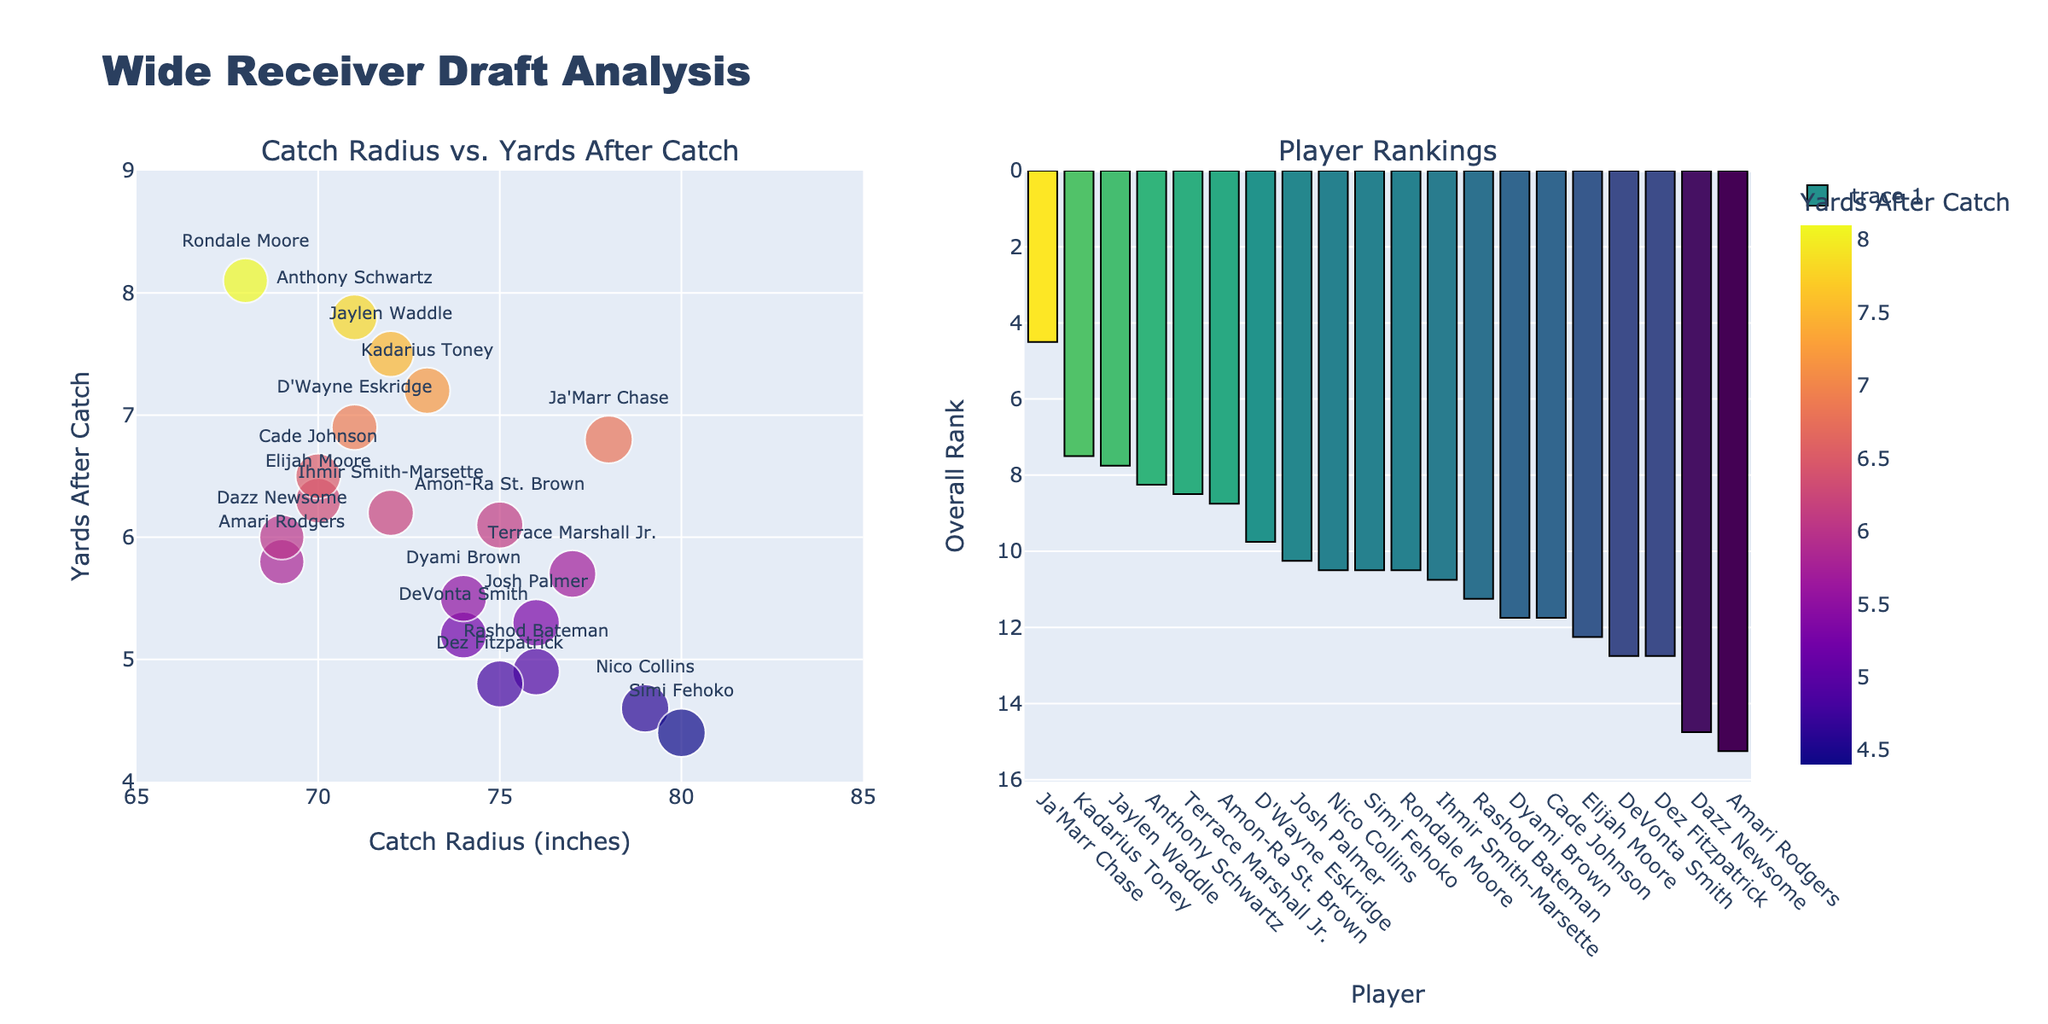What is the genre with the highest average word count? From the "Average Word Count" subplot, the highest bar belongs to the Fantasy genre.
Answer: Fantasy Which genre has the shortest chapter overall? Referring to the "Shortest Chapter" subplot, the shortest bar is for the Young Adult genre.
Answer: Young Adult Compare the standard deviations of Science Fiction and Horror; which is larger? In the "Standard Deviation" subplot, Science Fiction has a standard deviation of 2200 while Horror has 1500. Therefore, Science Fiction's standard deviation is larger.
Answer: Science Fiction What is the difference in the longest chapter length between Fantasy and Romance? In the "Longest Chapter" subplot, the longest chapter for Fantasy is 9500, and for Romance, it is 7500. The difference is 9500 - 7500.
Answer: 2000 Which two genres have the most similar average word count? From the "Average Word Count" subplot, Mystery (4500) and Literary Fiction (4200) have the closest values with a difference of 300.
Answer: Mystery and Literary Fiction How many genres have their longest chapters exceeding 8000 words? In the "Longest Chapter" subplot, the genres Fantasy (9500), Science Fiction (9000), and Historical Fiction (8500) have chapter lengths over 8000. That makes three genres.
Answer: Three Between Mystery and Thriller, which has a greater average word count and by how much? The "Average Word Count" subplot shows Mystery with 4500 and Thriller with 4300. The difference is 4500 - 4300.
Answer: Mystery by 200 Rank the genres by shortest chapter length in ascending order. By looking at the "Shortest Chapter" subplot, the order from lowest to highest is Young Adult (700), Horror (800), Romance (900), Magical Realism (950), Literary Fiction (1000), Mystery (1200), Historical Fiction (1300), Science Fiction (1400), Fantasy (1500), Thriller (1100).
Answer: Young Adult, Horror, Romance, Magical Realism, Literary Fiction, Mystery, Historical Fiction, Science Fiction, Fantasy, Thriller Which genre shows the smallest variance in chapter lengths? The "Standard Deviation" subplot illustrates that Horror has the smallest bar, indicating the smallest standard deviation of 1500.
Answer: Horror 